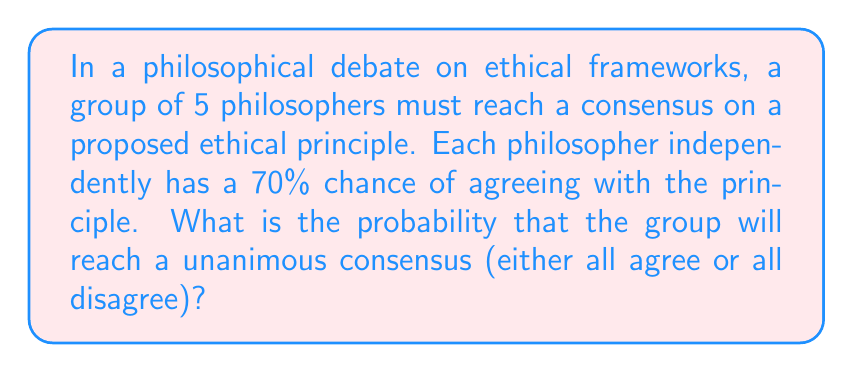Provide a solution to this math problem. Let's approach this step-by-step:

1) First, we need to calculate two probabilities:
   a) The probability that all philosophers agree
   b) The probability that all philosophers disagree

2) For all philosophers to agree:
   $$P(\text{all agree}) = 0.7^5 = 0.16807$$

3) For all philosophers to disagree:
   $$P(\text{all disagree}) = 0.3^5 = 0.00243$$

4) The probability of reaching a unanimous consensus is the sum of these two probabilities:

   $$P(\text{consensus}) = P(\text{all agree}) + P(\text{all disagree})$$
   $$P(\text{consensus}) = 0.16807 + 0.00243 = 0.17050$$

5) Therefore, the probability of reaching a unanimous consensus is approximately 0.17050 or 17.05%.

This problem illustrates the difficulty of reaching unanimous agreement in group decision-making processes, even when individual probabilities of agreement are relatively high. It relates to your philosophical studies by demonstrating how individual beliefs can aggregate in group settings, which has implications for understanding collective ethical decision-making.
Answer: 0.17050 